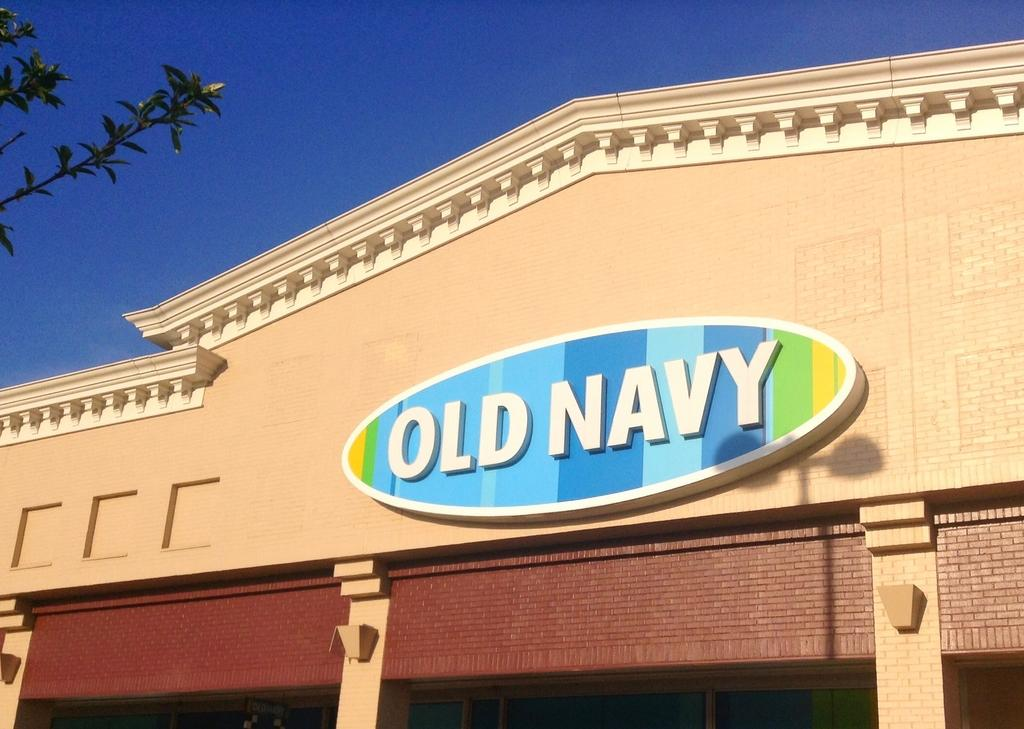What type of structure is present in the image? There is a building in the image. What can be seen on the building? There is text on the building. Where is the tree located in the image? The tree is in the top left corner of the image. What is visible in the background of the image? The sky is visible in the background of the image. What color is the sky in the image? The sky is blue in the image. How many letters are being delivered by the crow in the image? There is no crow present in the image, so no letters are being delivered. 